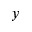Convert formula to latex. <formula><loc_0><loc_0><loc_500><loc_500>y</formula> 